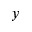Convert formula to latex. <formula><loc_0><loc_0><loc_500><loc_500>y</formula> 